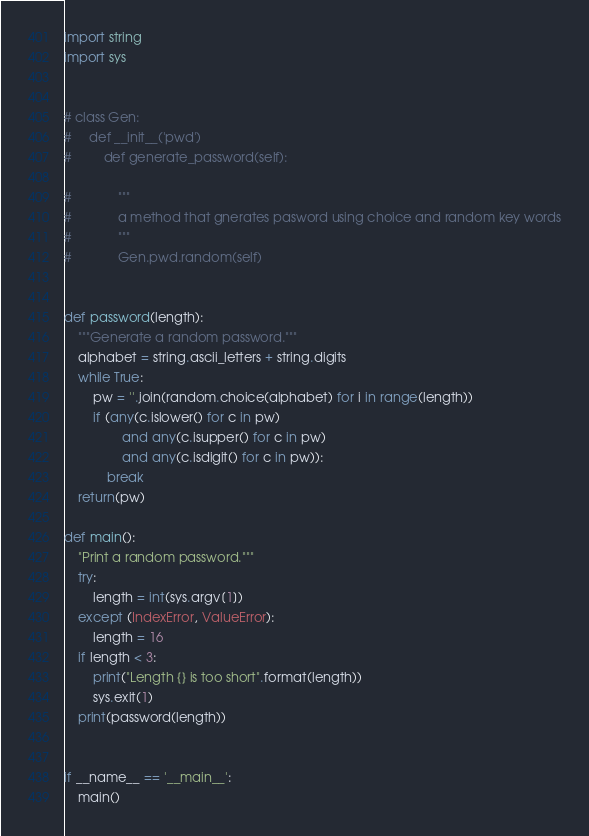<code> <loc_0><loc_0><loc_500><loc_500><_Python_>import string
import sys


# class Gen:
#     def __init__('pwd')
#         def generate_password(self):

#             """
#             a method that gnerates pasword using choice and random key words
#             """
#             Gen.pwd.random(self)
            
            
def password(length):
    """Generate a random password."""
    alphabet = string.ascii_letters + string.digits
    while True:
        pw = ''.join(random.choice(alphabet) for i in range(length))
        if (any(c.islower() for c in pw)
                and any(c.isupper() for c in pw)
                and any(c.isdigit() for c in pw)):
            break
    return(pw)

def main():
    "Print a random password."""
    try:
        length = int(sys.argv[1])
    except (IndexError, ValueError):
        length = 16
    if length < 3:
        print("Length {} is too short".format(length))
        sys.exit(1)
    print(password(length))


if __name__ == '__main__':
    main()</code> 